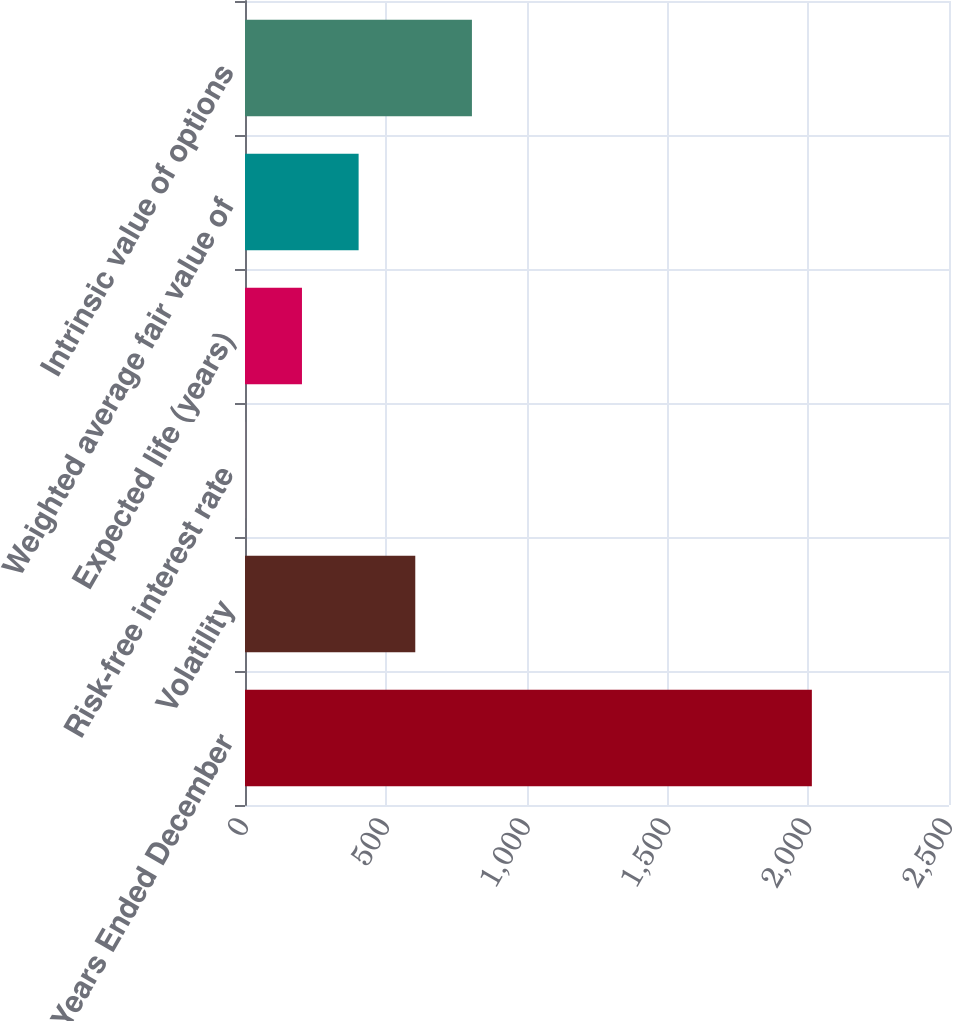<chart> <loc_0><loc_0><loc_500><loc_500><bar_chart><fcel>For the Years Ended December<fcel>Volatility<fcel>Risk-free interest rate<fcel>Expected life (years)<fcel>Weighted average fair value of<fcel>Intrinsic value of options<nl><fcel>2013<fcel>604.67<fcel>1.1<fcel>202.29<fcel>403.48<fcel>805.86<nl></chart> 